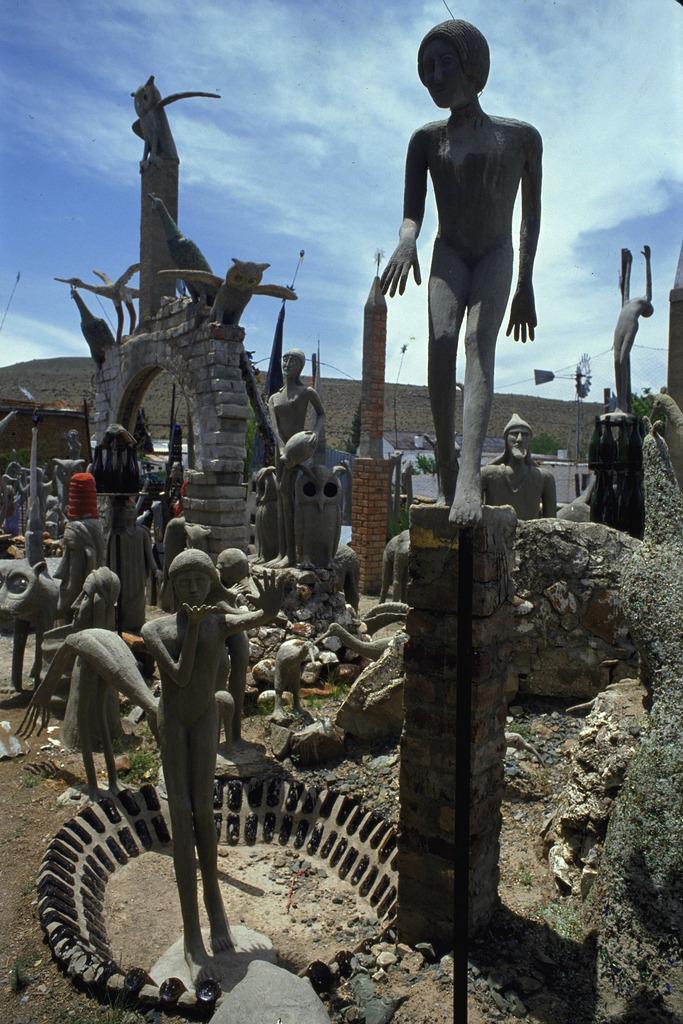Describe this image in one or two sentences. In this image I can see few statues, background I can see a building, and sky in white and blue color. 